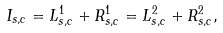<formula> <loc_0><loc_0><loc_500><loc_500>I _ { s , c } = L _ { s , c } ^ { 1 } + R _ { s , c } ^ { 1 } = L _ { s , c } ^ { 2 } + R _ { s , c } ^ { 2 } ,</formula> 